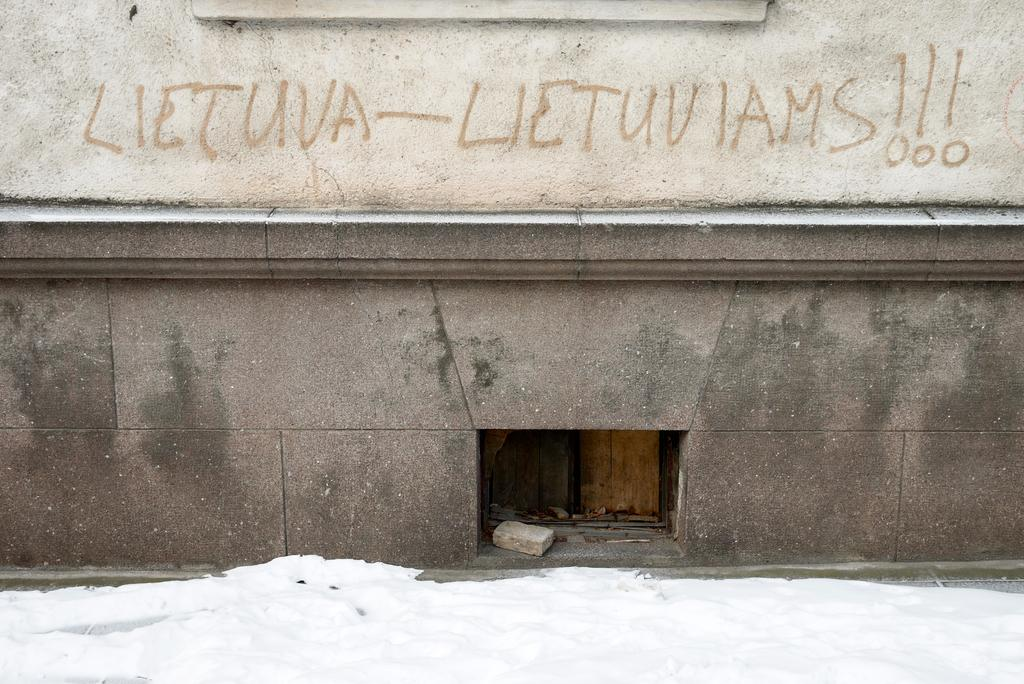What is present on the wall in the image? There is text on the wall in the image. What type of material is the stone in the image made of? The stone in the image is made of rock. What is the weather condition in the image? There is snow visible in the image, indicating a cold or wintry condition. Can you see a kiss happening between two people in the image? There is no indication of a kiss or any people in the image; it only features a wall with text, a stone, and snow. What is the zinc content of the stone in the image? There is no information about the zinc content of the stone in the image, as it is not mentioned in the provided facts. 